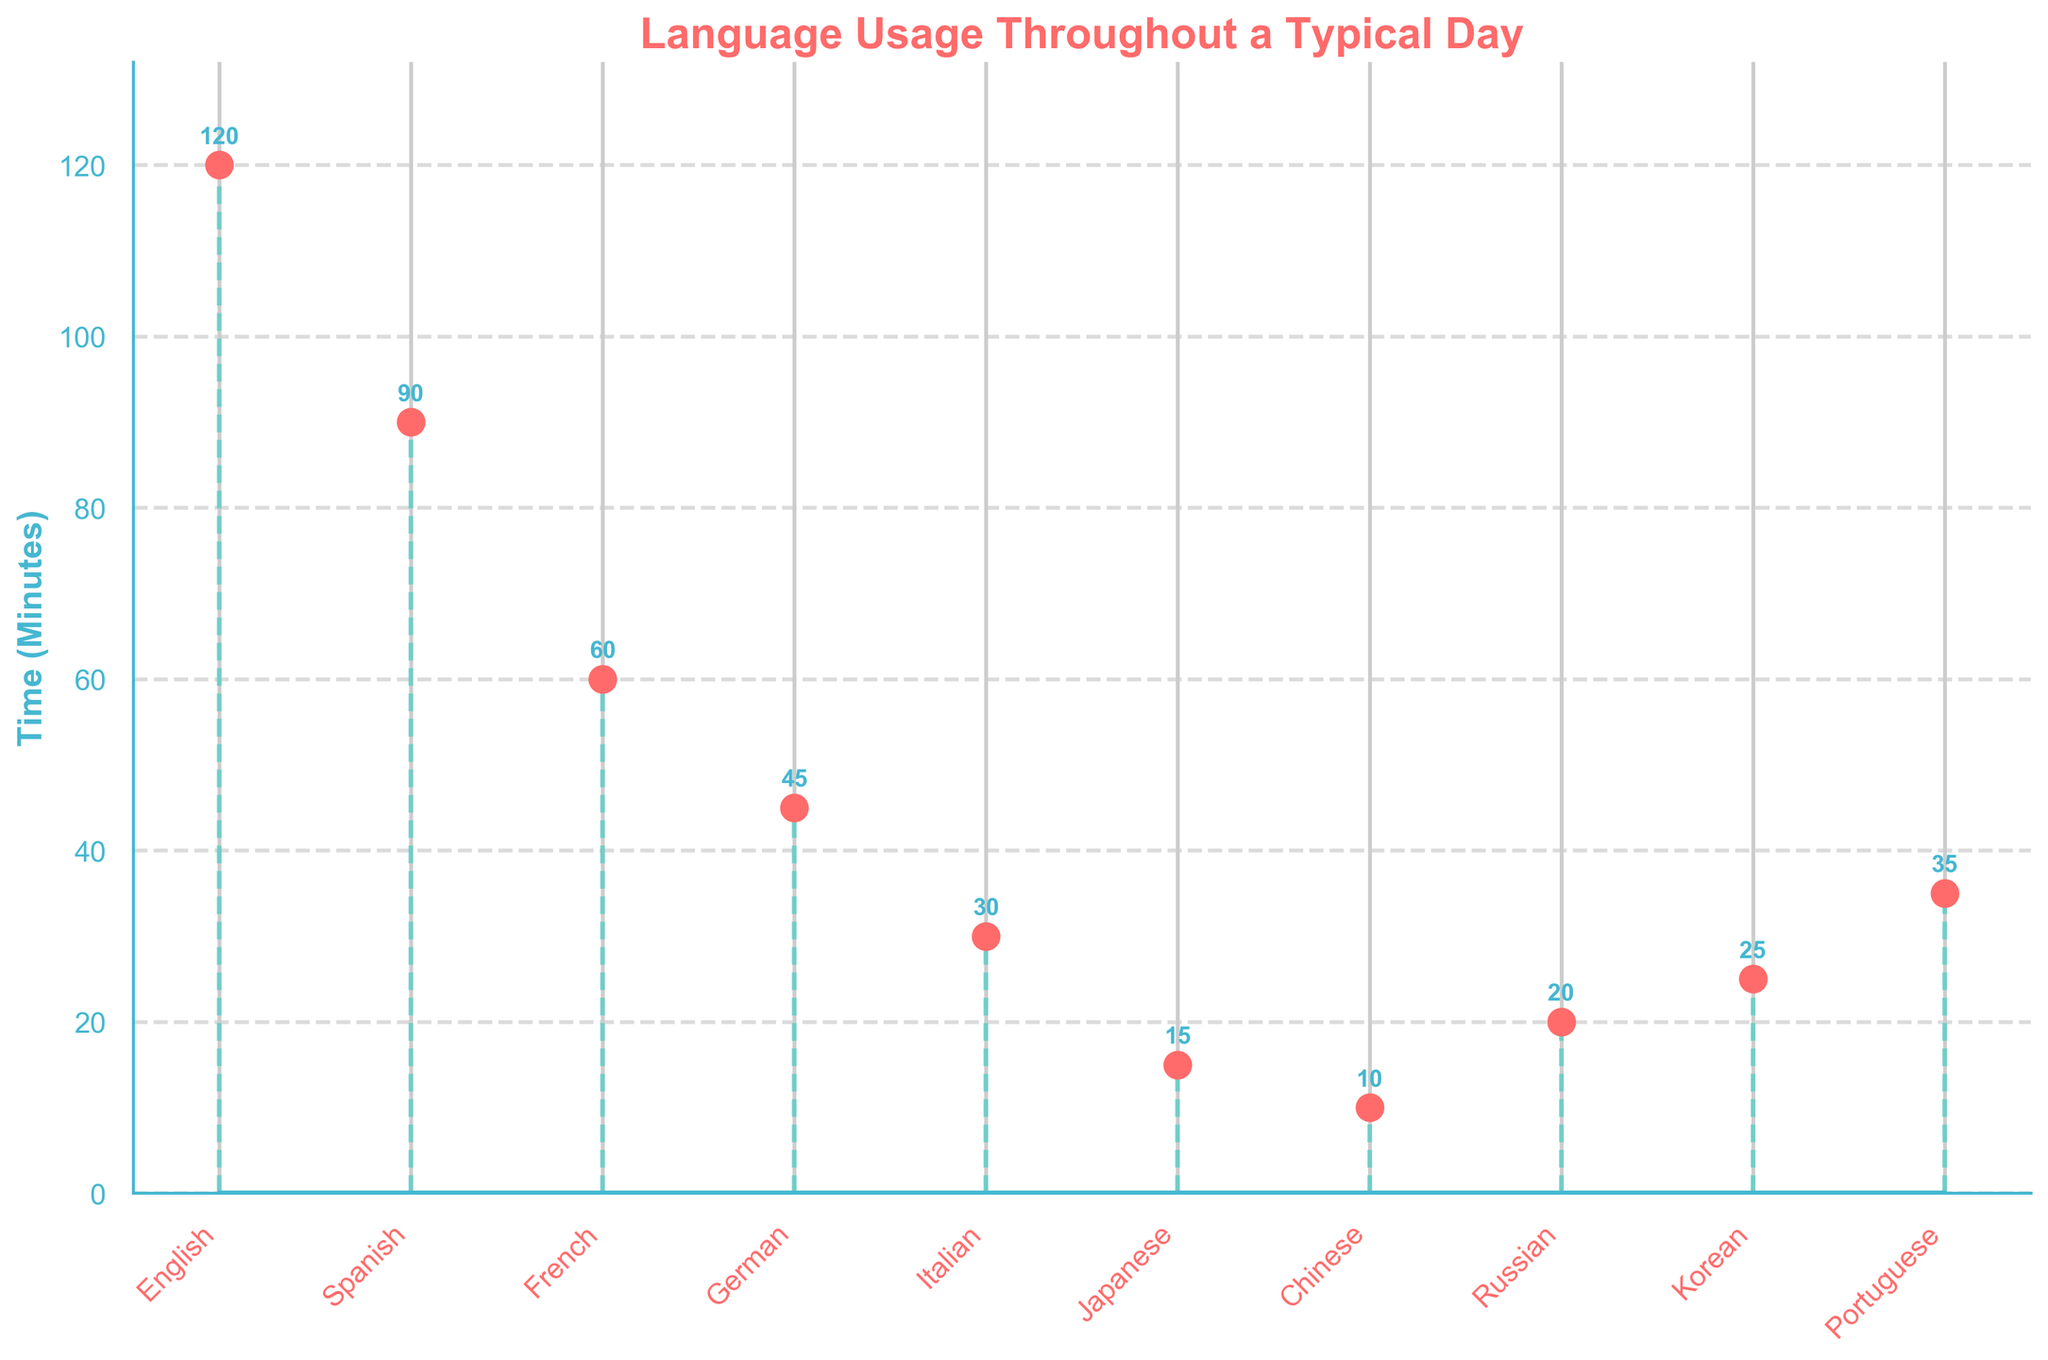What is the title of the figure? The title of the figure is displayed at the top part of the plot in a bold font. The title is a descriptive text explaining what the plot is about.
Answer: Language Usage Throughout a Typical Day What is the maximum time spent on a single language? Observe the y-axis and find the highest point among the plotted data points. The maximum value on the y-axis indicates the maximum time spent on a single language.
Answer: 120 minutes Which languages have usage times less than 20 minutes? Look at the y-axis values and identify the languages where the stem plot markers are below the 20-minute mark.
Answer: Chinese, Japanese What is the total time spent on all languages combined? Sum up the time for each language provided in the plot. The individual times are 120, 90, 60, 45, 30, 15, 10, 20, 25, and 35 minutes.
Answer: 450 minutes How much more time is spent on English compared to Spanish? Subtract the time spent on Spanish from the time spent on English. The times are 120 minutes for English and 90 minutes for Spanish.
Answer: 30 minutes Which language has the lowest usage time, and what is that time? Identify the data point with the lowest value along the y-axis.
Answer: Chinese, 10 minutes How many languages have a usage time of more than 30 minutes? Count the languages represented by data points above the 30-minute mark on the y-axis.
Answer: 6 Is the time spent on Portuguese greater than on Korean? Compare the y-axis value for Portuguese and Korean. Portuguese has a time of 35 minutes, and Korean has a time of 25 minutes.
Answer: Yes What is the average time spent on languages spoken for more than 20 minutes? Sum the times for languages spoken for more than 20 minutes (120, 90, 60, 45, 30, 35) and divide by the number of those languages (6).
Answer: 63.3 minutes Which language is spoken for exactly 45 minutes? Find the data point on the y-axis corresponding to 45 minutes and identify the associated language.
Answer: German 